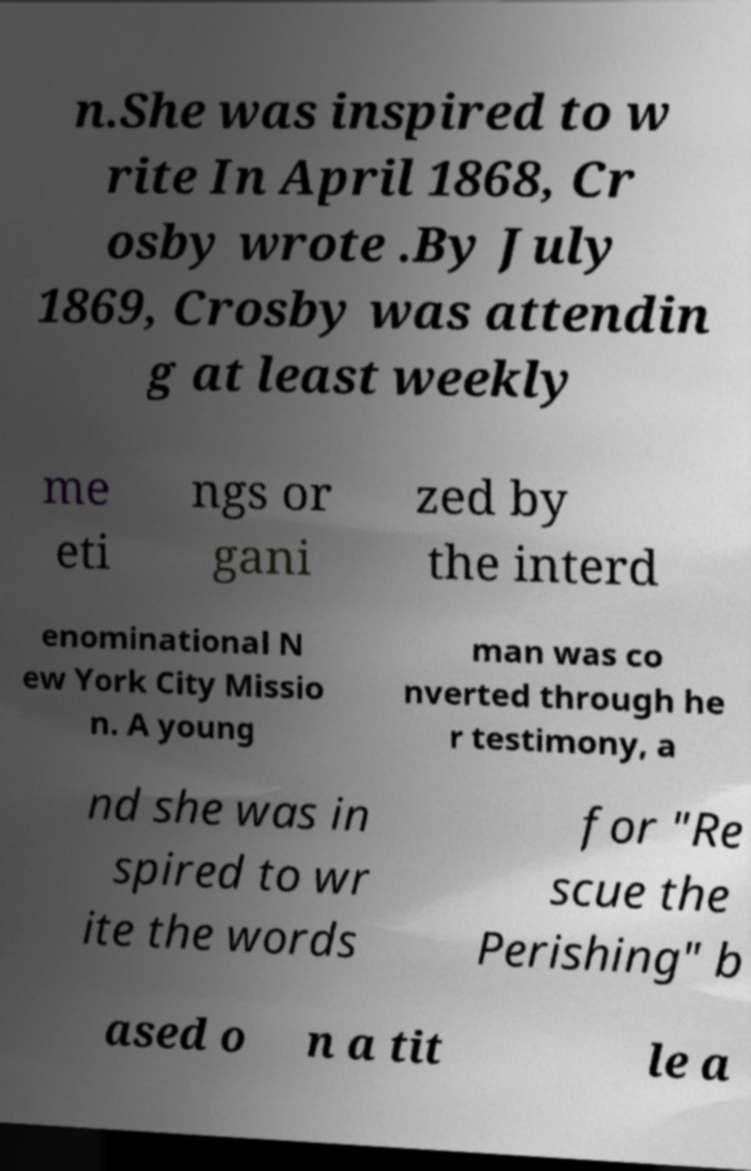Please identify and transcribe the text found in this image. n.She was inspired to w rite In April 1868, Cr osby wrote .By July 1869, Crosby was attendin g at least weekly me eti ngs or gani zed by the interd enominational N ew York City Missio n. A young man was co nverted through he r testimony, a nd she was in spired to wr ite the words for "Re scue the Perishing" b ased o n a tit le a 